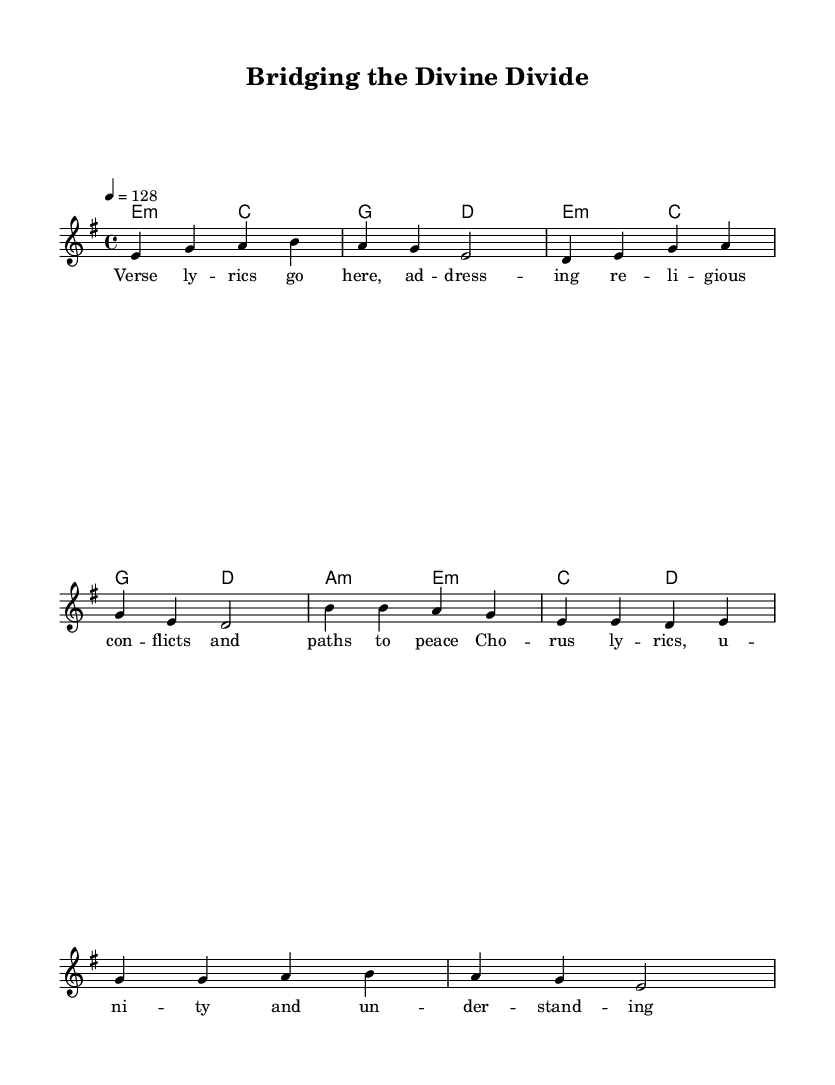What is the key signature of this music? The key signature is E minor, which has one sharp (F#) and indicates that the piece is centered around this minor scale.
Answer: E minor What is the time signature of this music? The time signature is 4/4, indicating that there are four beats in each measure and the quarter note receives one beat.
Answer: 4/4 What is the tempo indication provided in the sheet music? The tempo is given as 128 BPM (beats per minute), which informs the performer about the speed at which to play the piece.
Answer: 128 How many measures are there in the verse section? The verse section consists of four measures, as indicated by the musical notation.
Answer: Four What is the primary theme of this hard rock anthem? The primary theme revolves around addressing religious conflicts and paths to reconciliation, as suggested by the lyrics.
Answer: Religious conflicts What is the chord progression used in the verse? The chord progression in the verse is E minor, C, G, D, suggesting a typical rock structure emphasizing emotional depth.
Answer: E minor, C, G, D How many lines are present in the chorus lyrics? The chorus lyrics contain two lines, which provide a concise message emphasizing unity and understanding between faiths.
Answer: Two lines 